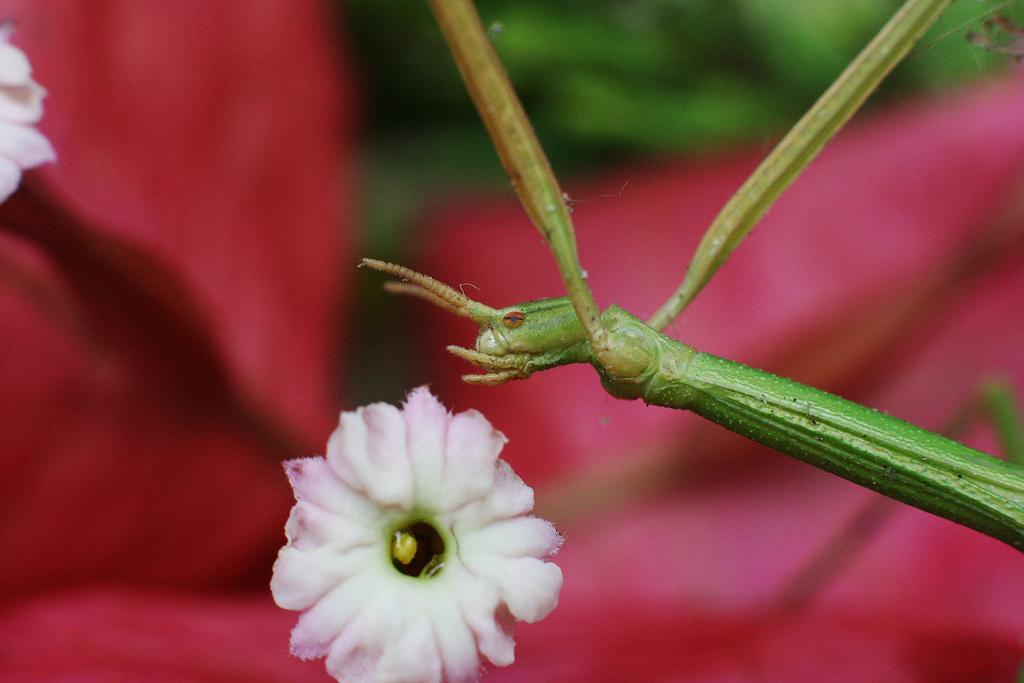Can you describe this image briefly? Front we can see a flower and an insect. Background it is blur. 